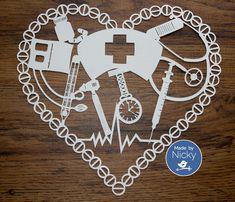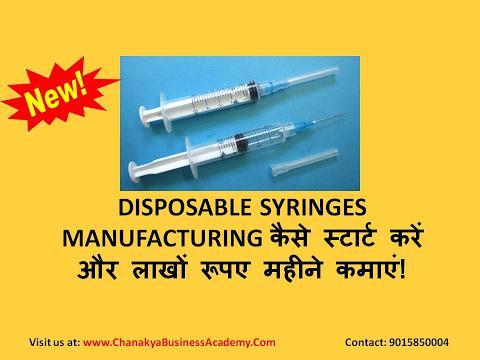The first image is the image on the left, the second image is the image on the right. Analyze the images presented: Is the assertion "The left image shows a clear cylinder with colored plastic on each end, and the right image shows something with a rightward-facing point" valid? Answer yes or no. No. The first image is the image on the left, the second image is the image on the right. For the images shown, is this caption "One syringe needle is covered." true? Answer yes or no. Yes. 